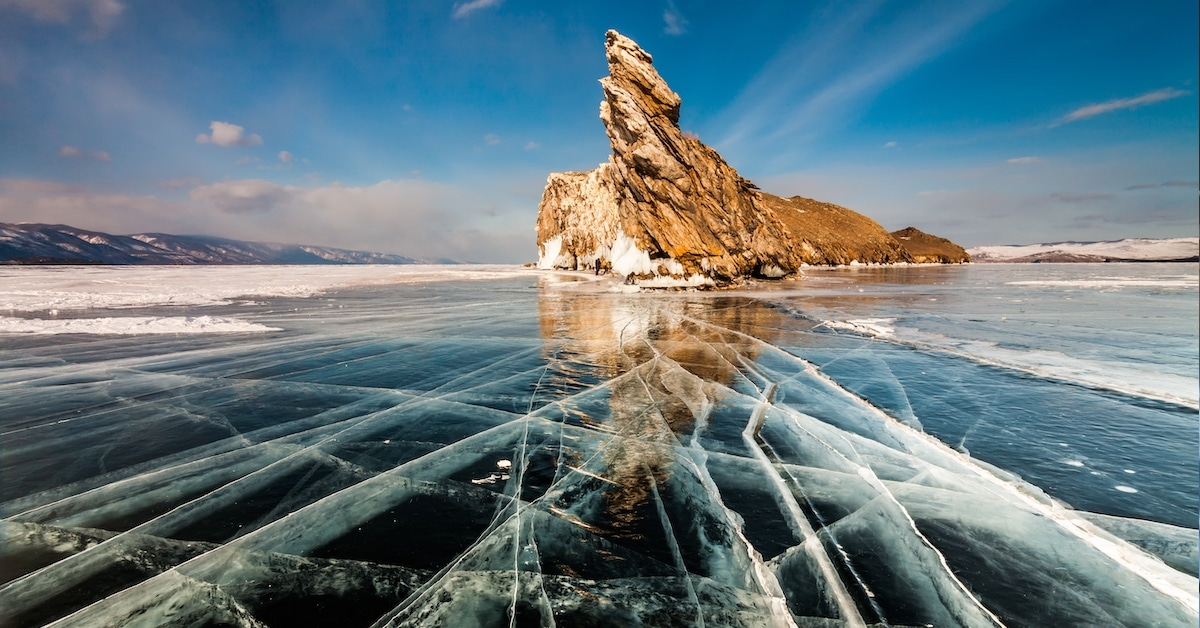Can you explain more about the ecological and scientific importance of Lake Baikal? Lake Baikal is often referred to as the 'Galapagos of Russia' due to its extraordinary biodiversity and unique ecosystems. It is home to thousands of species of plants and animals, many of which, like the Baikal seal, are endemic to the region. The lake is also a vital natural laboratory for scientific research, offering insights into climatic shifts, evolutionary biology, and limnology. Its ice cover patterns, water purity, and deep water mysteries provide valuable data crucial for environmental and geological studies. 